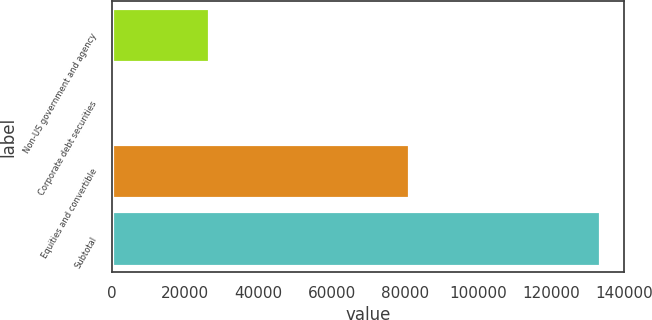Convert chart to OTSL. <chart><loc_0><loc_0><loc_500><loc_500><bar_chart><fcel>Non-US government and agency<fcel>Corporate debt securities<fcel>Equities and convertible<fcel>Subtotal<nl><fcel>26500<fcel>218<fcel>81252<fcel>133439<nl></chart> 